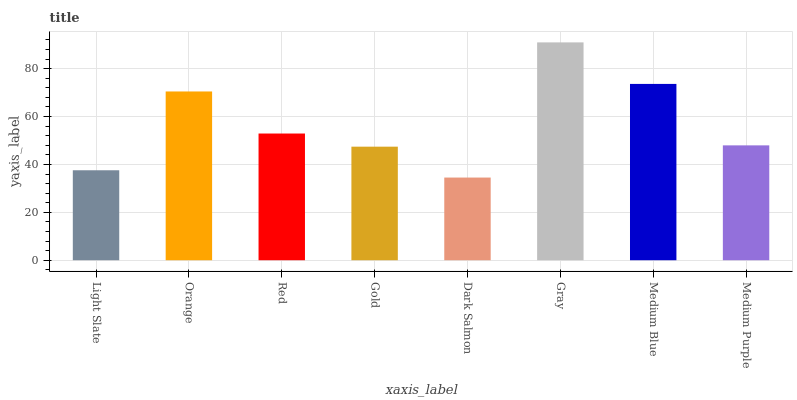Is Dark Salmon the minimum?
Answer yes or no. Yes. Is Gray the maximum?
Answer yes or no. Yes. Is Orange the minimum?
Answer yes or no. No. Is Orange the maximum?
Answer yes or no. No. Is Orange greater than Light Slate?
Answer yes or no. Yes. Is Light Slate less than Orange?
Answer yes or no. Yes. Is Light Slate greater than Orange?
Answer yes or no. No. Is Orange less than Light Slate?
Answer yes or no. No. Is Red the high median?
Answer yes or no. Yes. Is Medium Purple the low median?
Answer yes or no. Yes. Is Medium Blue the high median?
Answer yes or no. No. Is Red the low median?
Answer yes or no. No. 